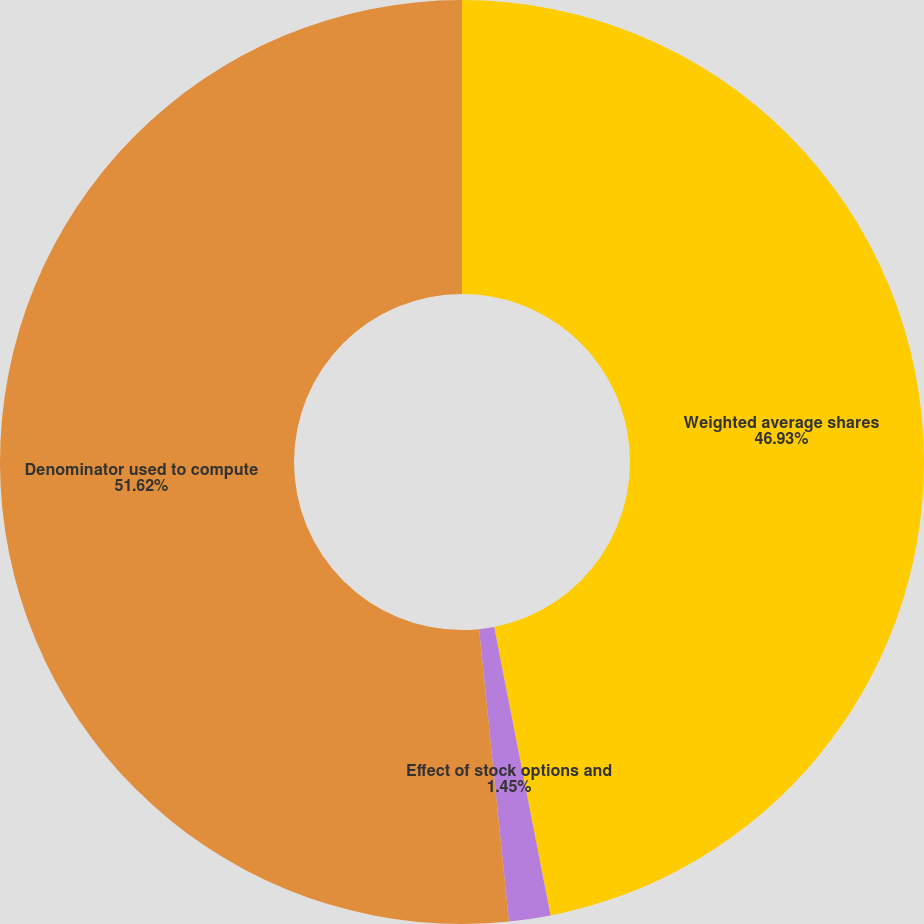<chart> <loc_0><loc_0><loc_500><loc_500><pie_chart><fcel>Weighted average shares<fcel>Effect of stock options and<fcel>Denominator used to compute<nl><fcel>46.93%<fcel>1.45%<fcel>51.62%<nl></chart> 